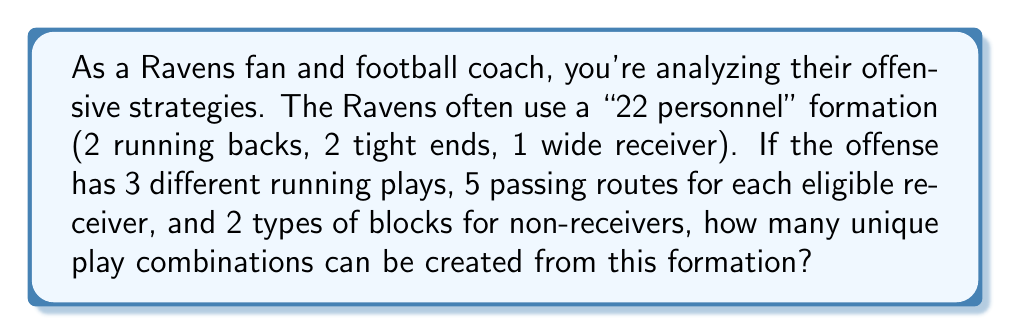Can you answer this question? Let's break this down step-by-step:

1) In a "22 personnel" formation, we have:
   - 2 running backs (RB)
   - 2 tight ends (TE)
   - 1 wide receiver (WR)
   - 1 quarterback (QB)

2) For each play, we need to determine:
   - Run or pass
   - If run, which of the 3 running plays
   - If pass, which routes for the eligible receivers
   - Blocking assignments for non-receivers

3) Let's calculate:
   a) Run plays: 
      - 3 different running plays
      - 2 RBs could be the ball carrier
      $$3 \times 2 = 6$$ run play options

   b) Pass plays:
      - 5 route options for each eligible receiver
      - 4 eligible receivers (2 RB, 2 TE, 1 WR)
      $$5^4 = 625$$ route combinations

   c) Blocking assignments:
      - 2 types of blocks for non-receivers
      - In a pass play, typically 5 players block (5 offensive linemen)
      $$2^5 = 32$$ blocking combinations

4) Total combinations:
   - For run plays: 6 options
   - For pass plays: 625 route combinations × 32 blocking combinations
   
   $$\text{Total} = 6 + (625 \times 32) = 6 + 20,000 = 20,006$$
Answer: 20,006 unique play combinations 